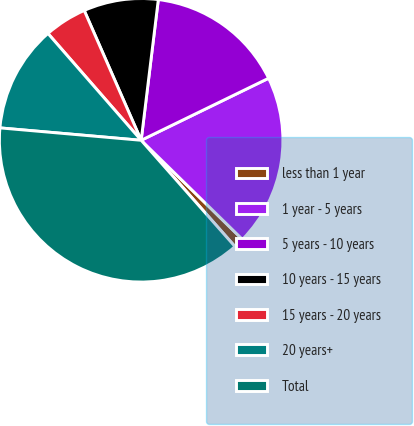<chart> <loc_0><loc_0><loc_500><loc_500><pie_chart><fcel>less than 1 year<fcel>1 year - 5 years<fcel>5 years - 10 years<fcel>10 years - 15 years<fcel>15 years - 20 years<fcel>20 years+<fcel>Total<nl><fcel>1.16%<fcel>19.54%<fcel>15.86%<fcel>8.51%<fcel>4.84%<fcel>12.19%<fcel>37.91%<nl></chart> 